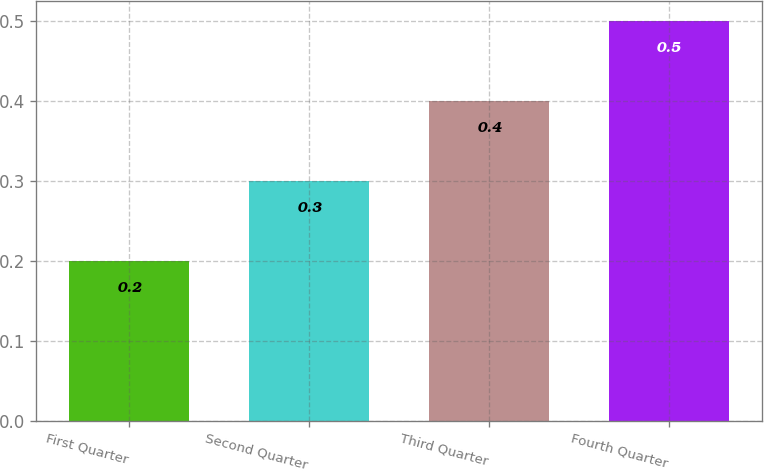Convert chart to OTSL. <chart><loc_0><loc_0><loc_500><loc_500><bar_chart><fcel>First Quarter<fcel>Second Quarter<fcel>Third Quarter<fcel>Fourth Quarter<nl><fcel>0.2<fcel>0.3<fcel>0.4<fcel>0.5<nl></chart> 